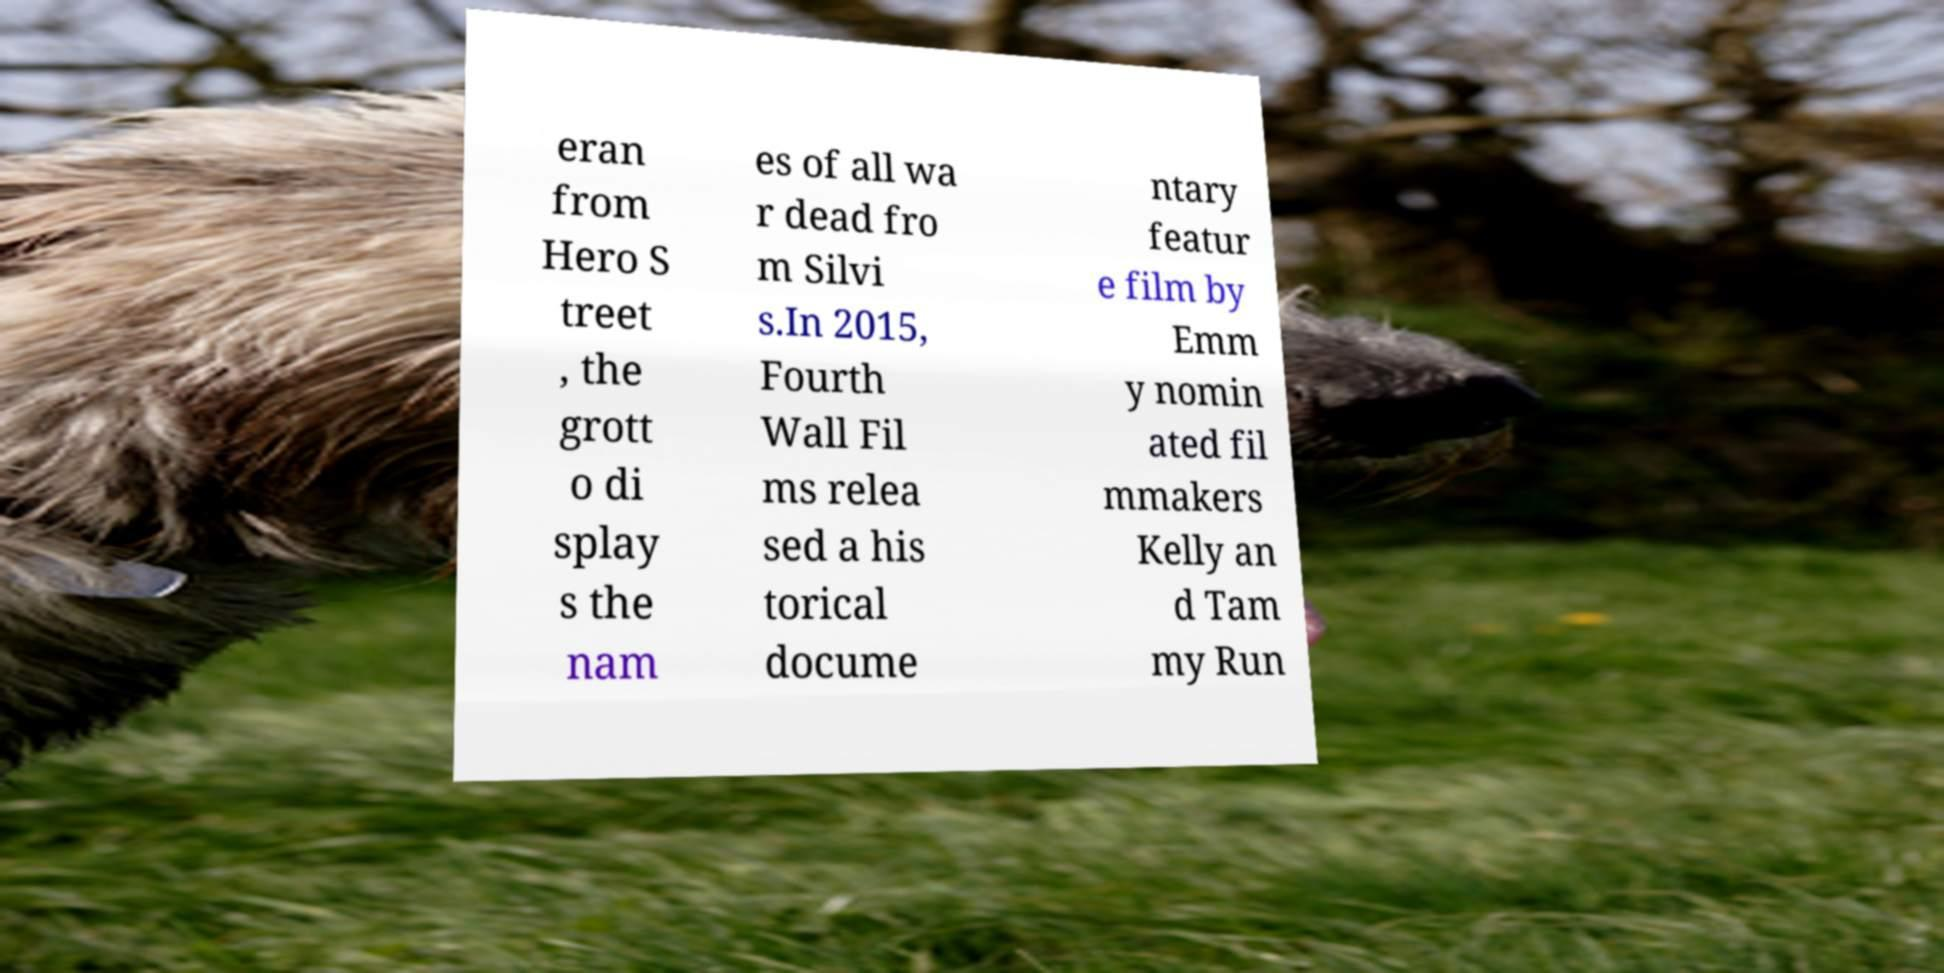Please read and relay the text visible in this image. What does it say? eran from Hero S treet , the grott o di splay s the nam es of all wa r dead fro m Silvi s.In 2015, Fourth Wall Fil ms relea sed a his torical docume ntary featur e film by Emm y nomin ated fil mmakers Kelly an d Tam my Run 